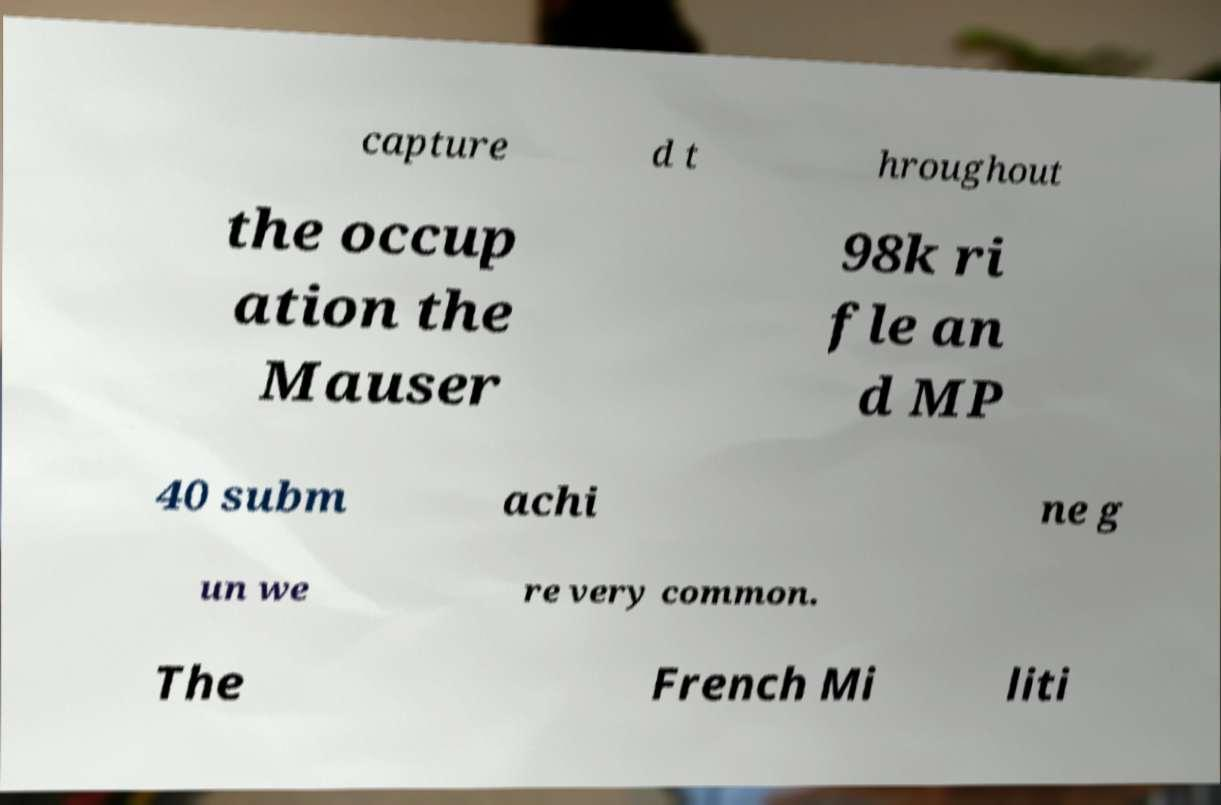Can you read and provide the text displayed in the image?This photo seems to have some interesting text. Can you extract and type it out for me? capture d t hroughout the occup ation the Mauser 98k ri fle an d MP 40 subm achi ne g un we re very common. The French Mi liti 